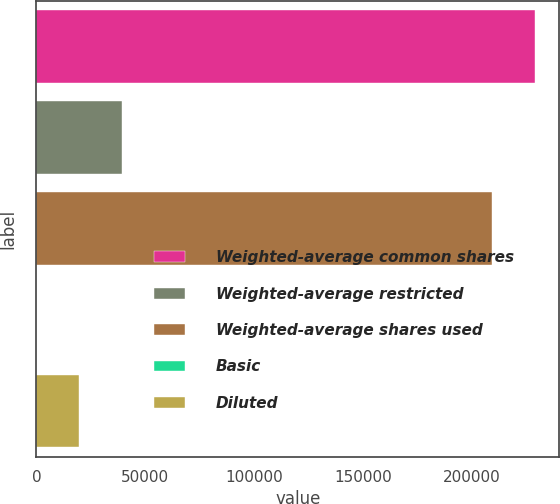<chart> <loc_0><loc_0><loc_500><loc_500><bar_chart><fcel>Weighted-average common shares<fcel>Weighted-average restricted<fcel>Weighted-average shares used<fcel>Basic<fcel>Diluted<nl><fcel>228844<fcel>39337.7<fcel>209177<fcel>3.41<fcel>19670.6<nl></chart> 